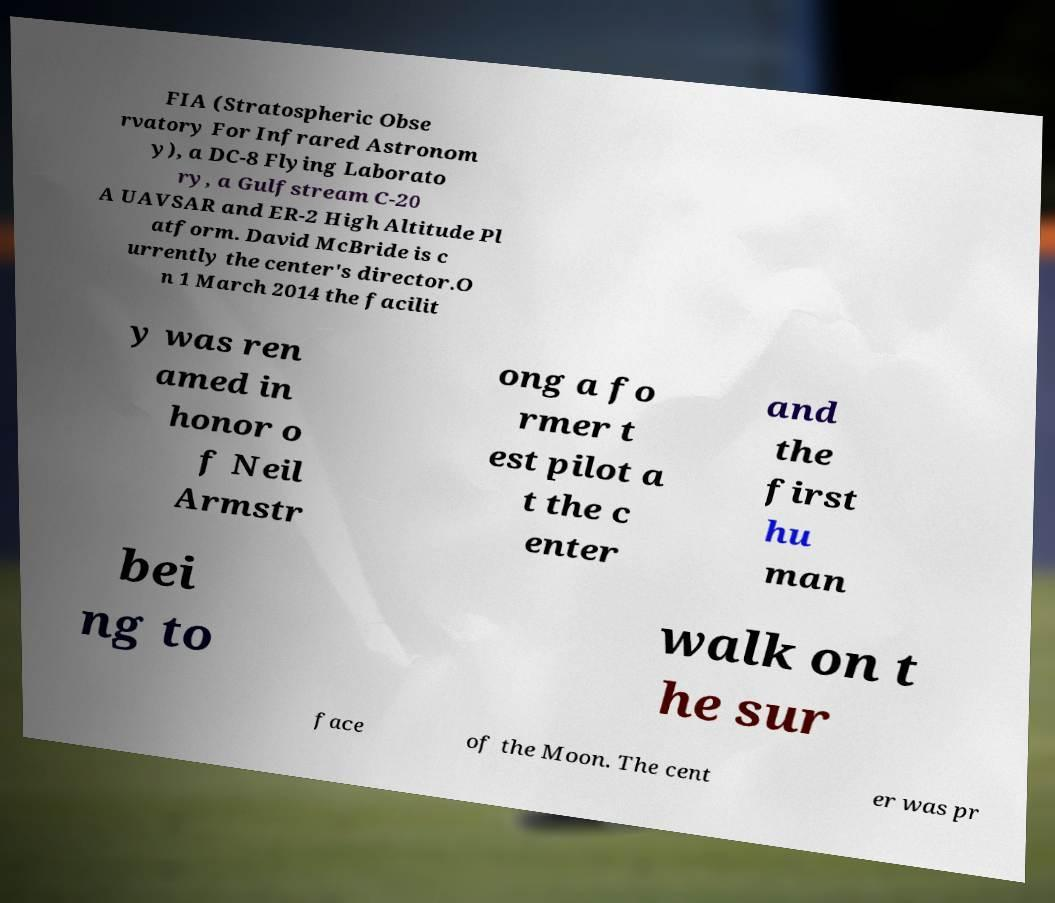Please identify and transcribe the text found in this image. FIA (Stratospheric Obse rvatory For Infrared Astronom y), a DC-8 Flying Laborato ry, a Gulfstream C-20 A UAVSAR and ER-2 High Altitude Pl atform. David McBride is c urrently the center's director.O n 1 March 2014 the facilit y was ren amed in honor o f Neil Armstr ong a fo rmer t est pilot a t the c enter and the first hu man bei ng to walk on t he sur face of the Moon. The cent er was pr 